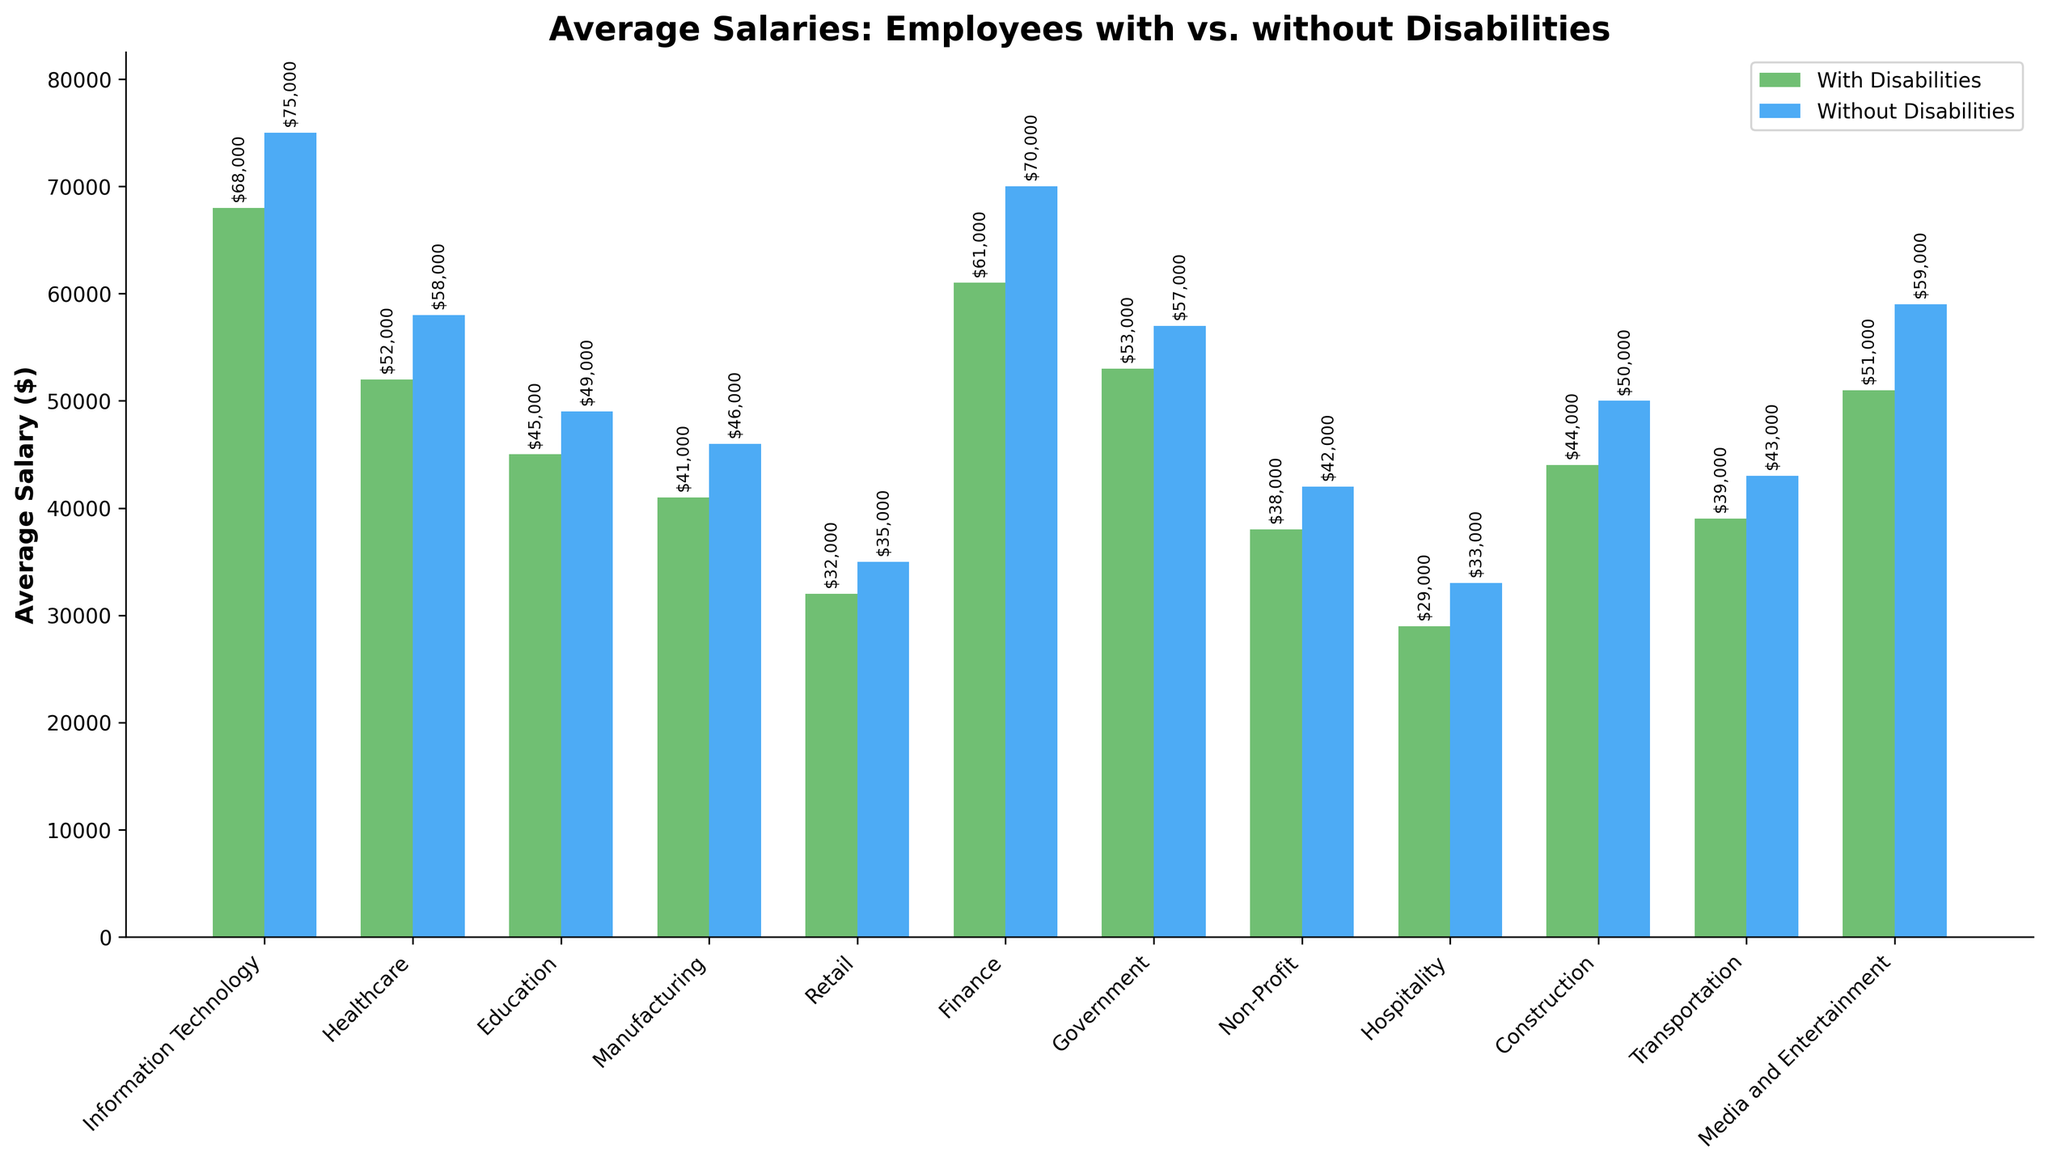Which job sector has the highest average salary for employees with disabilities? Look at the height of the green bars representing employees with disabilities; the tallest one indicates the highest average salary.
Answer: Information Technology What is the difference in average salary between employees with and without disabilities in the Government sector? Find the height of the bars for the Government sector and subtract the value of the green bar (with disabilities) from the blue bar (without disabilities): $57000 - $53000 = $4000.
Answer: $4000 In which sector is the salary gap between employees with and without disabilities the smallest? Find the difference between the heights of the green and blue bars for each sector and identify the one with the smallest gap. For the Non-Profit sector, $42000 - $38000 = $4000; that's the smallest.
Answer: Non-Profit Calculate the average salary of disabled employees across all job sectors shown. Sum the heights of the green bars and divide by the number of sectors (12): ($68000 + $52000 + $45000 + $41000 + $32000 + $61000 + $53000 + $38000 + $29000 + $44000 + $39000 + $51000) / 12 = $45,250.
Answer: $45,250 Which job sector shows the largest discrepancy in average salaries between employees with and without disabilities? Check the differences between the green and blue bars for each sector. Information Technology has the largest discrepancy: $75000 - $68000 = $7000.
Answer: Information Technology Are there any sectors where the average salary for employees with disabilities is higher than those without disabilities? Look at each sector's pair of bars; none of the green bars representing employees with disabilities are taller than the blue bars representing employees without disabilities.
Answer: No How does the average salary for employees with disabilities in the Healthcare sector compare to that in the Retail sector? Compare the heights of the green bars in both sectors; Healthcare: $52000, Retail: $32000.
Answer: $52000 is higher than $32000 What is the combined average salary for employees with and without disabilities in the Manufacturing sector? Add the heights of the bars for Manufacturing: $41000 (with disabilities) + $46000 (without disabilities) = $87000.
Answer: $87000 